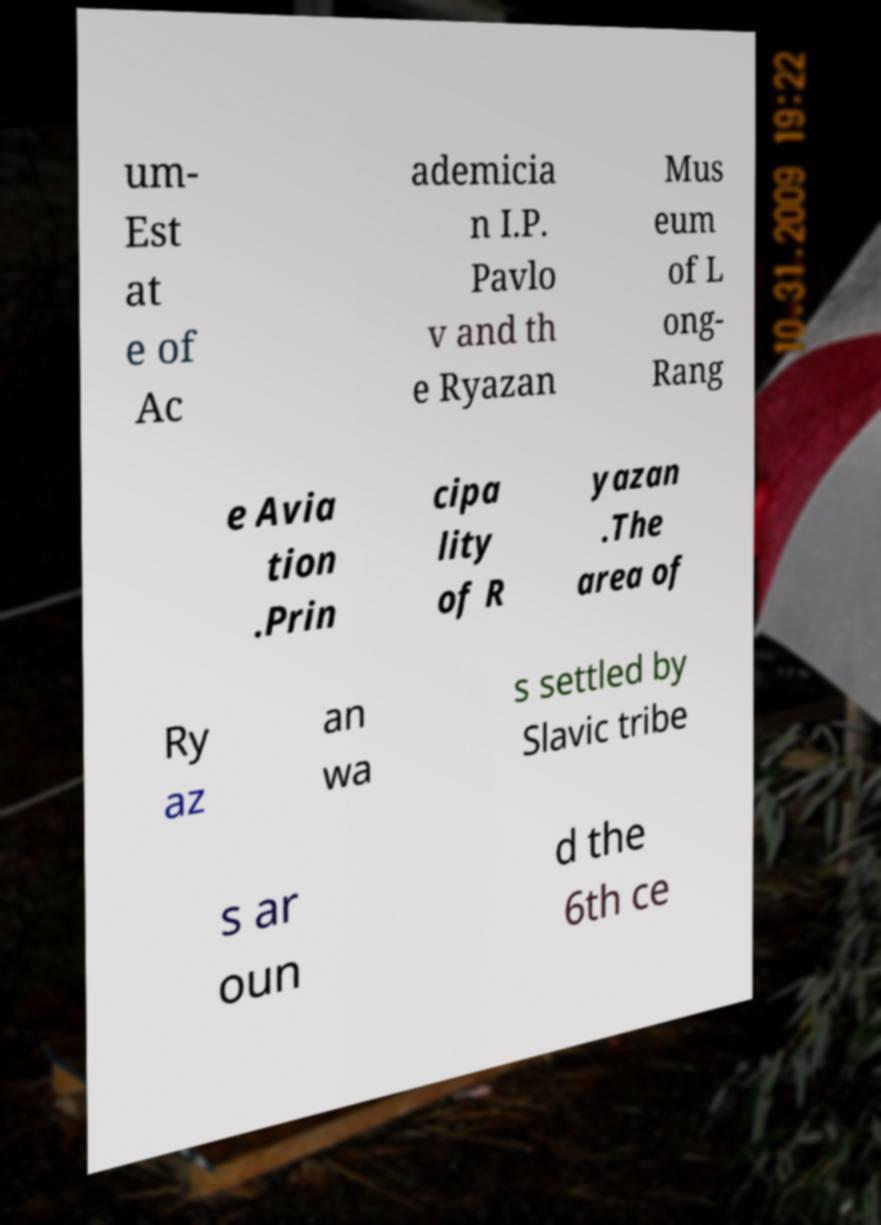For documentation purposes, I need the text within this image transcribed. Could you provide that? um- Est at e of Ac ademicia n I.P. Pavlo v and th e Ryazan Mus eum of L ong- Rang e Avia tion .Prin cipa lity of R yazan .The area of Ry az an wa s settled by Slavic tribe s ar oun d the 6th ce 